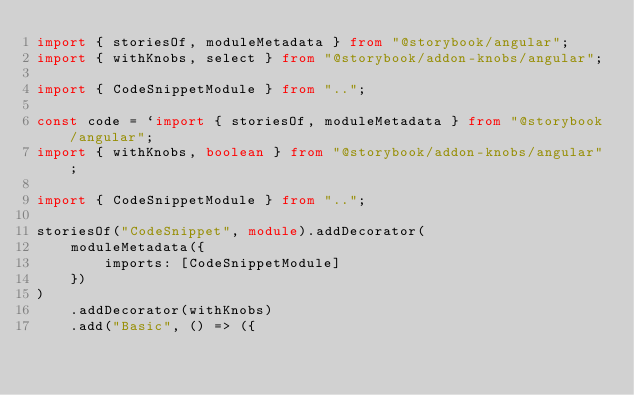Convert code to text. <code><loc_0><loc_0><loc_500><loc_500><_TypeScript_>import { storiesOf, moduleMetadata } from "@storybook/angular";
import { withKnobs, select } from "@storybook/addon-knobs/angular";

import { CodeSnippetModule } from "..";

const code = `import { storiesOf, moduleMetadata } from "@storybook/angular";
import { withKnobs, boolean } from "@storybook/addon-knobs/angular";

import { CodeSnippetModule } from "..";

storiesOf("CodeSnippet", module).addDecorator(
	moduleMetadata({
		imports: [CodeSnippetModule]
	})
)
	.addDecorator(withKnobs)
	.add("Basic", () => ({</code> 